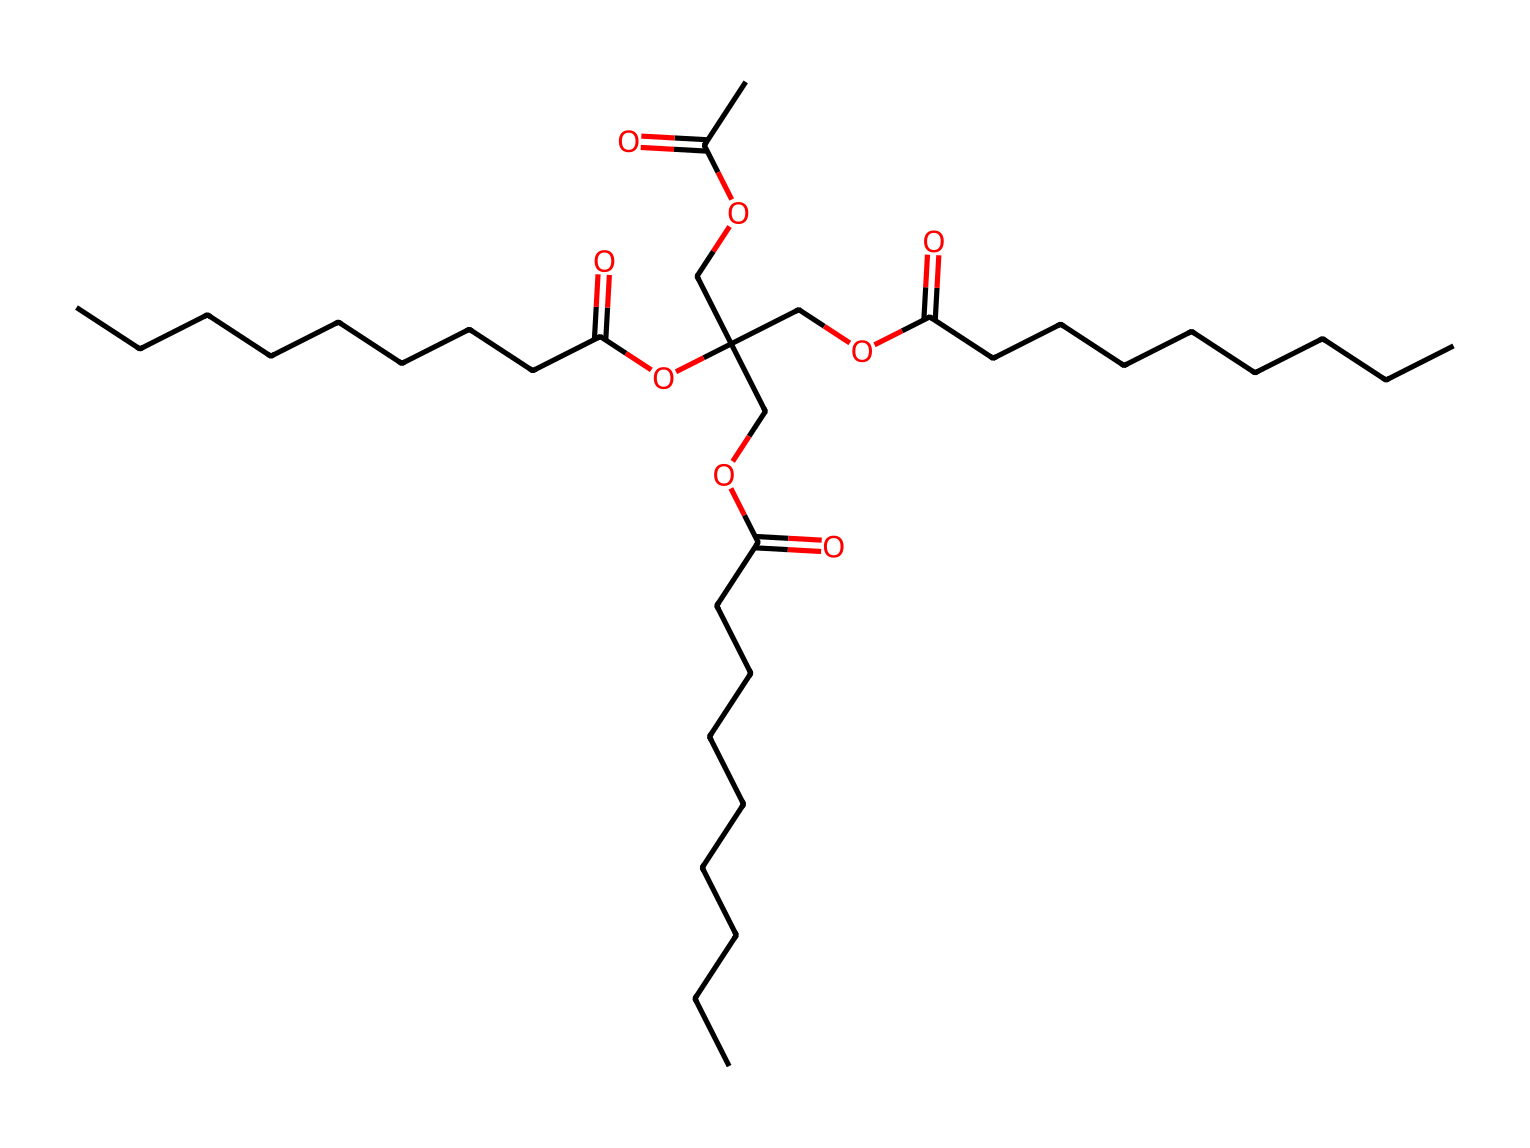What type of lipid is represented in this structure? The chemical depicts a triglyceride structure, characterized by three fatty acid chains linked to a glycerol backbone. This classifies it specifically as a triglyceride.
Answer: triglyceride How many carbon atoms are in the longest fatty acid chain? By analyzing the structure, the longest fatty acid chain contains 8 carbon atoms (noting the "CCCCCCCC" segment) connected in a straight chain.
Answer: 8 What functional group is present in the molecule? The chemical structure contains ester groups, which can be identified by the presence of the -COO- linkage that connects fatty acids to the glycerol backbone.
Answer: ester What is the total number of ester bonds in the molecule? Counting the ester linkages from each fatty acid to the glycerol unit reveals that there are three ester bonds in total for this triglyceride.
Answer: 3 Which type of fatty acid chain is indicated by the presence of the "CC(=O)" at the beginning? The initial portion "CC(=O)O" signifies a fatty acid with a carbonyl group, indicating the presence of a medium-chain fatty acid due to the length of the carbon chain involved.
Answer: medium-chain How many oxygen atoms are present in the entire structure? By counting the oxygen atoms present within both the ester linkages and the functional groups, there are a total of 6 oxygen atoms in this molecule.
Answer: 6 